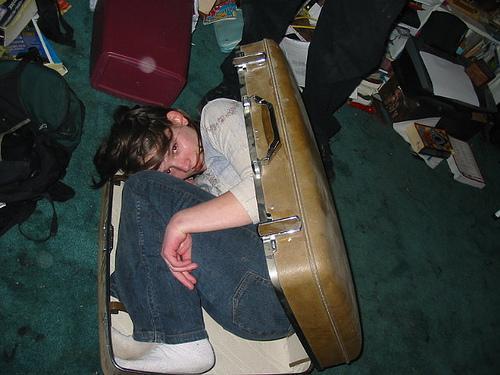How many suitcases are there?
Give a very brief answer. 2. How many people are there?
Give a very brief answer. 2. 